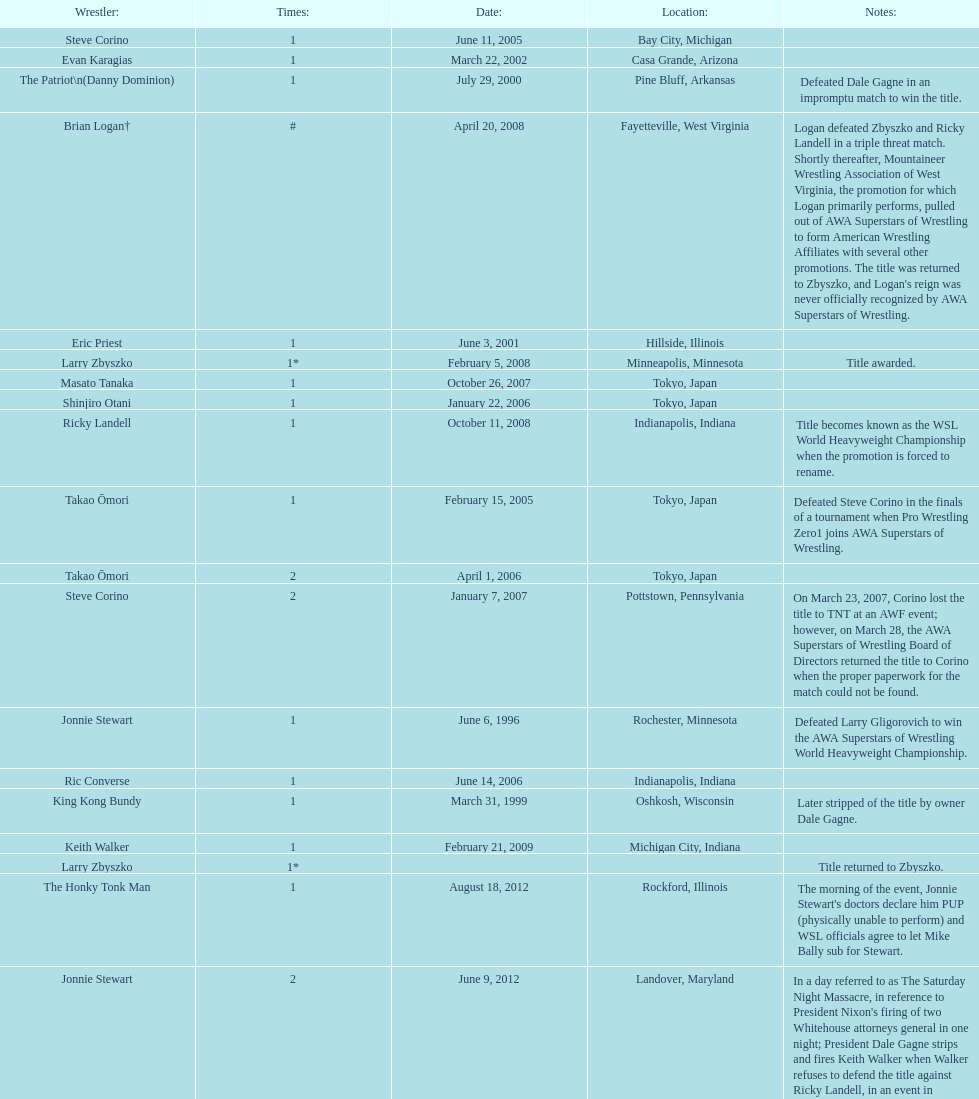Who is listed before keith walker? Ricky Landell. 